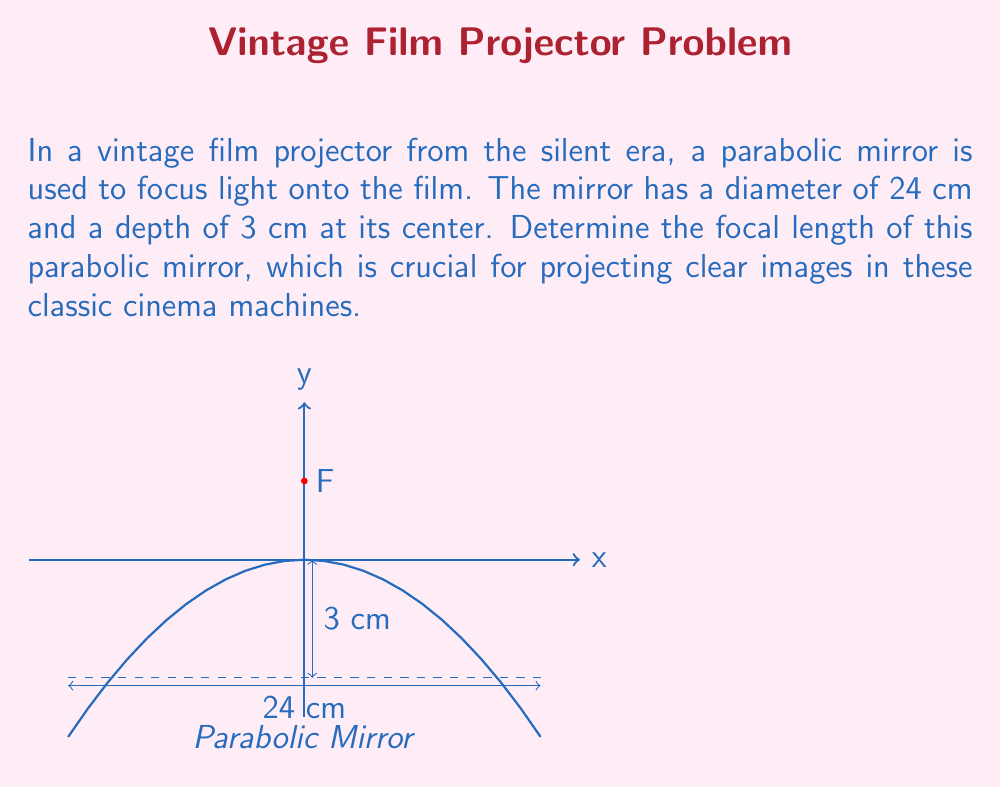Can you solve this math problem? Let's approach this step-by-step:

1) The equation of a parabola with vertex at the origin and axis of symmetry along the y-axis is:

   $$y = \frac{1}{4p}x^2$$

   where $p$ is the focal length.

2) We know that the parabola passes through the point (12, -3), as the diameter is 24 cm and the depth is 3 cm. Let's substitute these coordinates:

   $$-3 = \frac{1}{4p}(12)^2$$

3) Simplify:
   
   $$-3 = \frac{144}{4p}$$

4) Multiply both sides by $4p$:

   $$-12p = 144$$

5) Divide both sides by -12:

   $$p = -12$$

6) The focal length is the absolute value of $p$:

   $$\text{Focal length} = |p| = 12$$

Therefore, the focal length of the parabolic mirror is 12 cm.

This focal length ensures that parallel light rays hitting the mirror will converge at a point 12 cm in front of the vertex, creating a bright, focused beam ideal for projecting film in these vintage machines.
Answer: 12 cm 